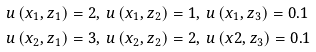<formula> <loc_0><loc_0><loc_500><loc_500>u \left ( x _ { 1 } , z _ { 1 } \right ) & = 2 , \ u \left ( x _ { 1 } , z _ { 2 } \right ) = 1 , \ u \left ( x _ { 1 } , z _ { 3 } \right ) = 0 . 1 \\ u \left ( x _ { 2 } , z _ { 1 } \right ) & = 3 , \ u \left ( x _ { 2 } , z _ { 2 } \right ) = 2 , \ u \left ( x 2 , z _ { 3 } \right ) = 0 . 1</formula> 